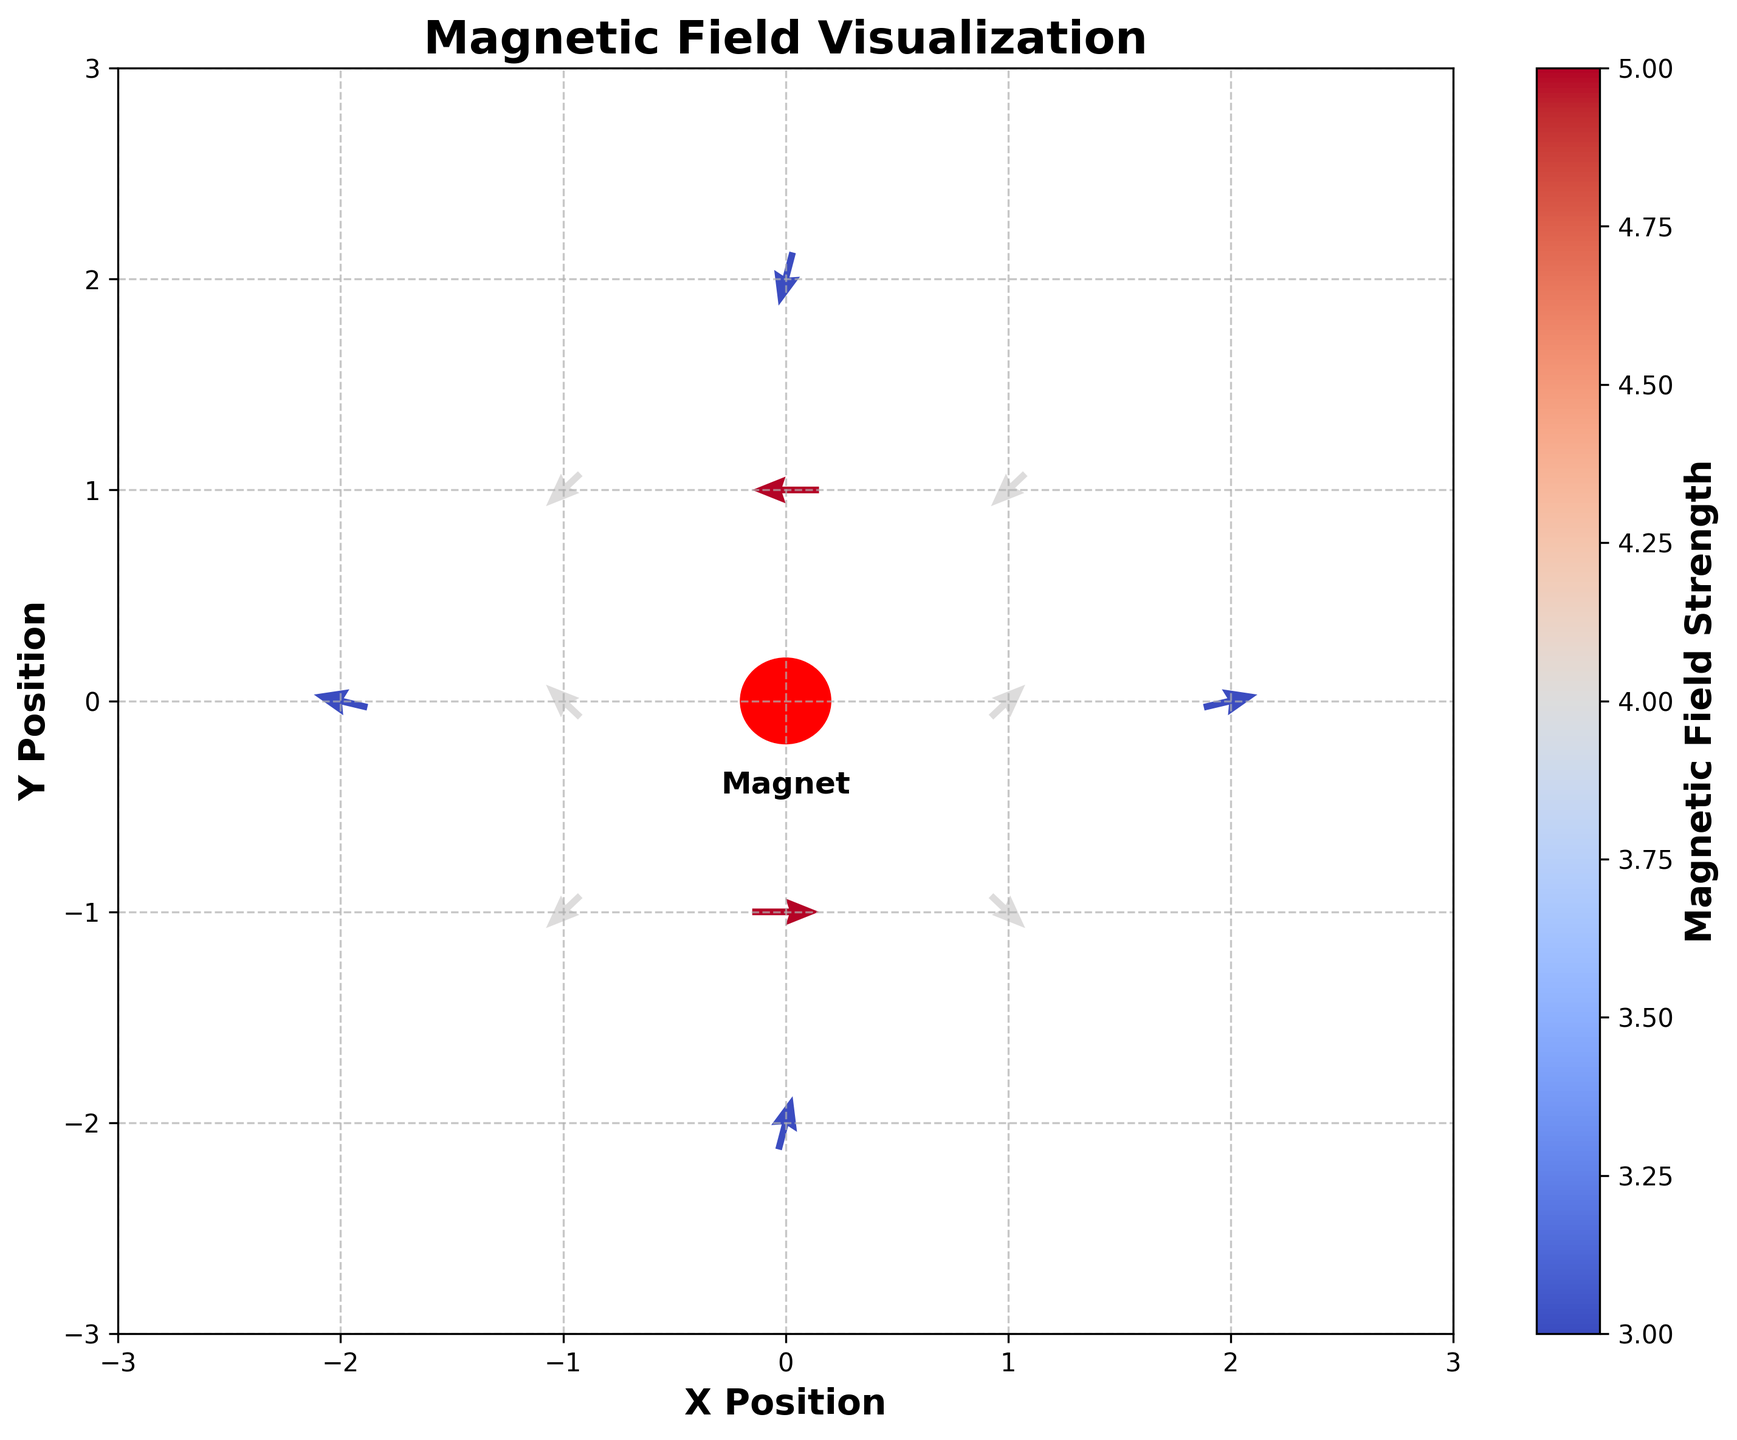What is the title of the plot? Look at the top of the plot where the title is usually located. The title is "Magnetic Field Visualization."
Answer: Magnetic Field Visualization What do the arrows in the plot represent? The arrows in the plot represent the direction and strength of the magnetic field around the toy magnets.
Answer: Direction and strength of the magnetic field Which axis is labeled "X Position"? Look at the axis labels; the X Position label is found along the horizontal axis (bottom of the plot).
Answer: Horizontal axis What colors are used to indicate magnetic field strength in the plot? The plot uses a colorbar with coolwarm colormap, typically ranging from cool colors (blue) to warm colors (red).
Answer: Blue and Red How many data points are shown in the plot? Count the number of arrows or data points visible in the plot. There are 12 arrows representing the data points.
Answer: 12 Which direction is the magnetic field strongest at the origin (0,0)? Observe the arrow at the origin. The arrow points upward, indicating the magnetic field direction at that point.
Answer: Upward What is the color of the arrow at position (-2, 0)? Check the arrow color at the position (-2, 0) on the plot. It is in the cool color range.
Answer: Blue Compare the arrow strength at positions (1, 0) and (-1, 0). Which has a stronger magnetic field? Check the color intensity of the arrows at these positions; darker red indicates stronger field. The arrow at (1, 0) is red while (-1, 0) is also red, but we can see their strengths are the same in the color bar.
Answer: Both are equal Which arrow has the weakest magnetic field strength? Look for the lightest-colored arrow in the plot according to the color bar. The arrows at (2, 0), (0, 2), and (0, -2) have the weakest field strengths.
Answer: (2, 0), (0, 2), (0, -2) Is the magnetic field at position (0, 1) pointing towards or away from the magnet? Observe the direction of the arrow at position (0, 1), which points horizontally left towards the origin. This indicates it is pointing towards the magnet.
Answer: Towards 